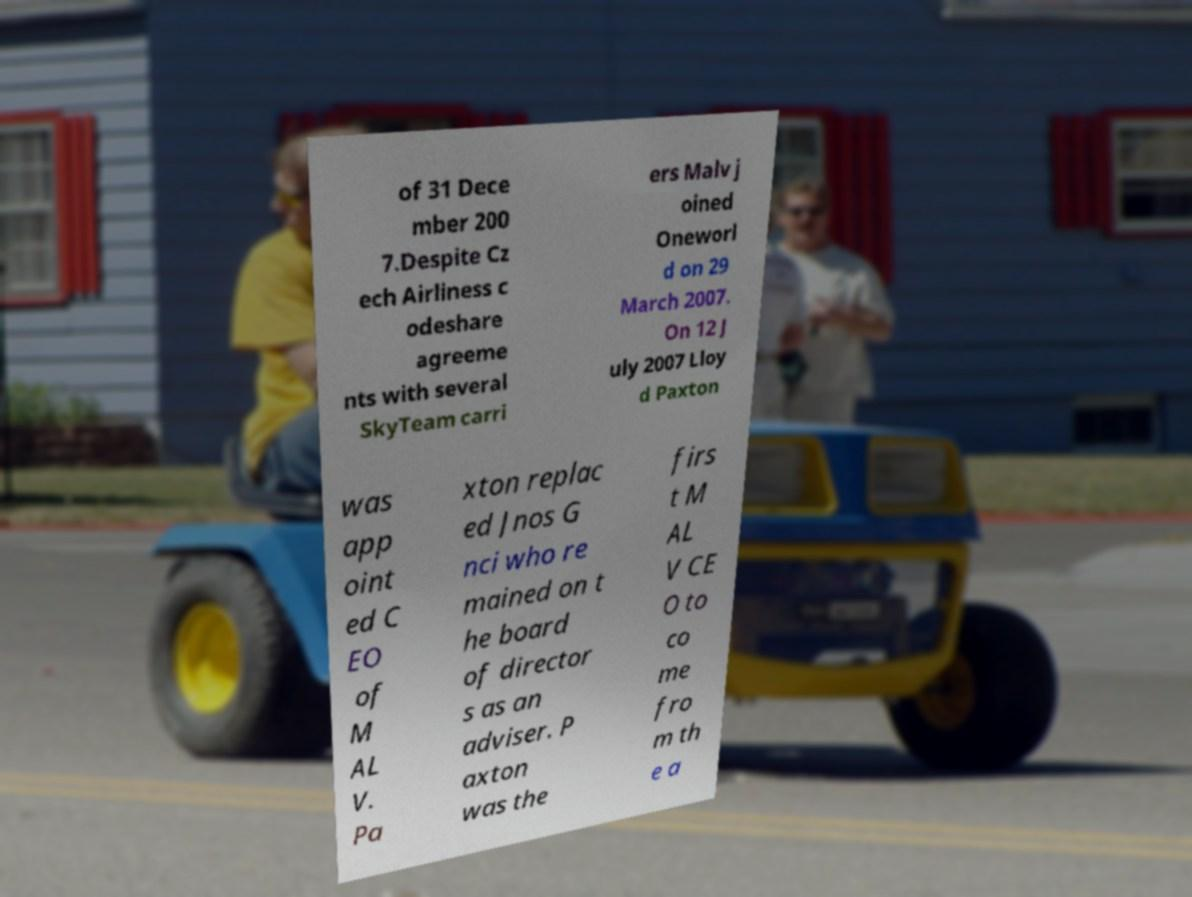Please identify and transcribe the text found in this image. of 31 Dece mber 200 7.Despite Cz ech Airliness c odeshare agreeme nts with several SkyTeam carri ers Malv j oined Oneworl d on 29 March 2007. On 12 J uly 2007 Lloy d Paxton was app oint ed C EO of M AL V. Pa xton replac ed Jnos G nci who re mained on t he board of director s as an adviser. P axton was the firs t M AL V CE O to co me fro m th e a 